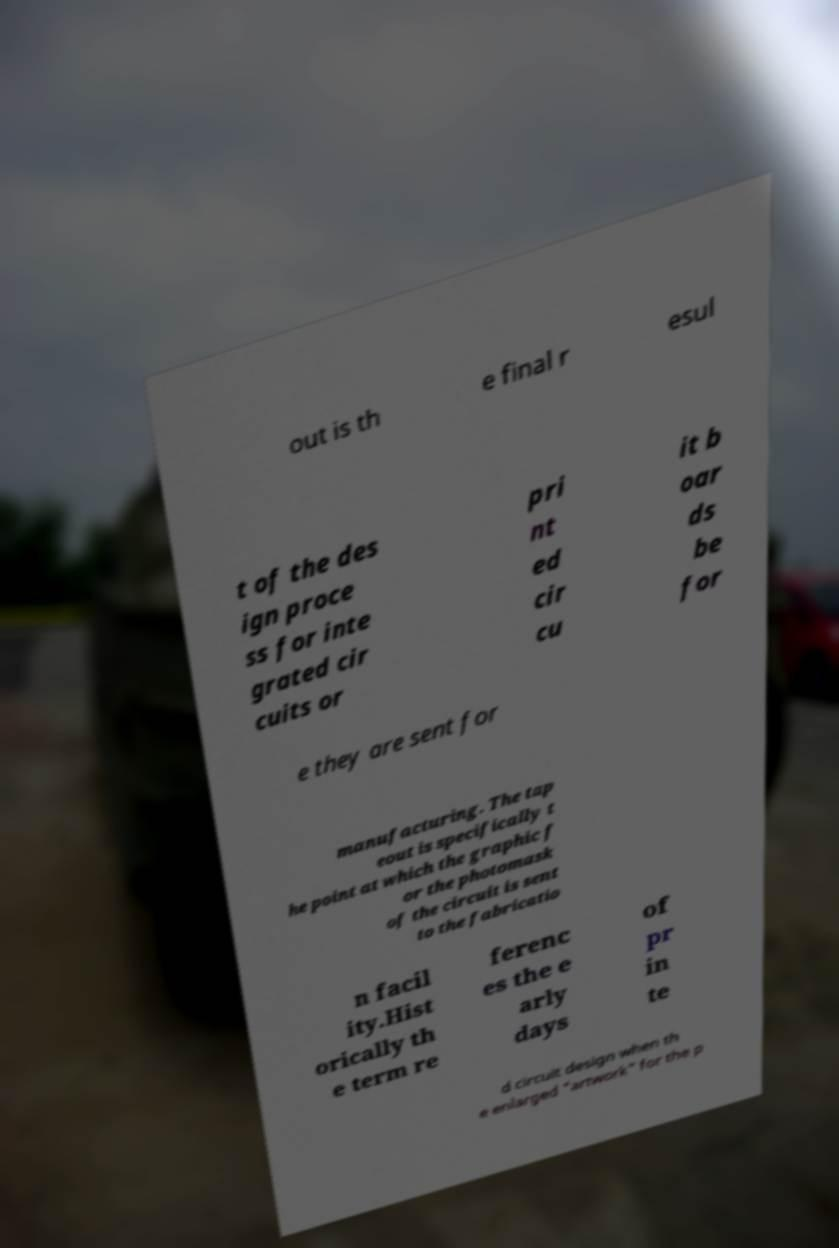Can you read and provide the text displayed in the image?This photo seems to have some interesting text. Can you extract and type it out for me? out is th e final r esul t of the des ign proce ss for inte grated cir cuits or pri nt ed cir cu it b oar ds be for e they are sent for manufacturing. The tap eout is specifically t he point at which the graphic f or the photomask of the circuit is sent to the fabricatio n facil ity.Hist orically th e term re ferenc es the e arly days of pr in te d circuit design when th e enlarged "artwork" for the p 